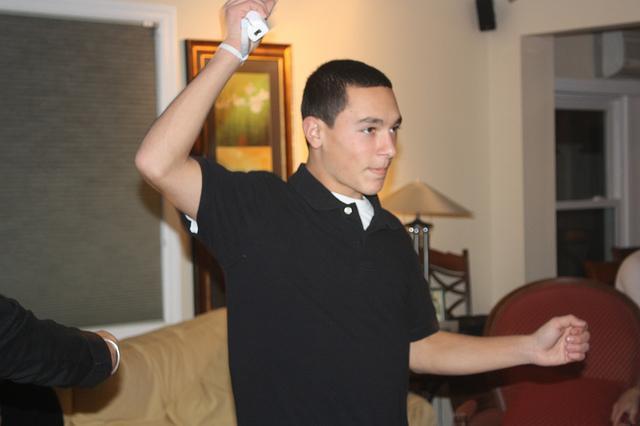How many people are in the photo?
Give a very brief answer. 2. How many kites are flying?
Give a very brief answer. 0. 